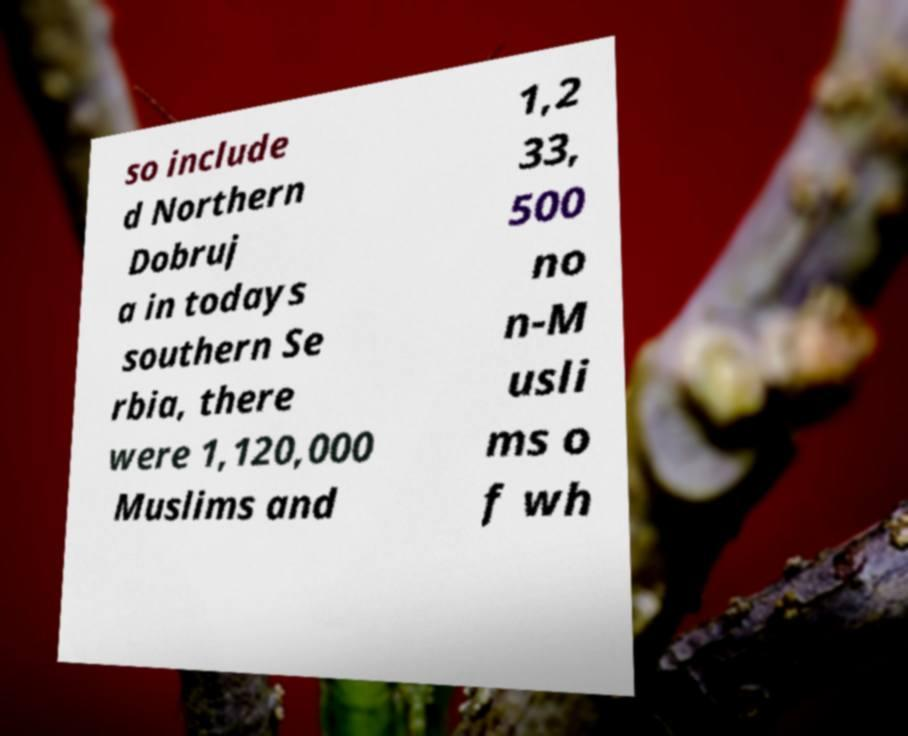I need the written content from this picture converted into text. Can you do that? so include d Northern Dobruj a in todays southern Se rbia, there were 1,120,000 Muslims and 1,2 33, 500 no n-M usli ms o f wh 